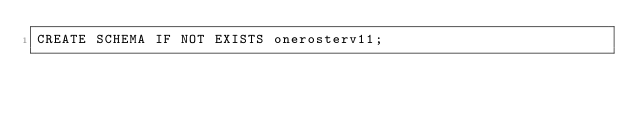Convert code to text. <code><loc_0><loc_0><loc_500><loc_500><_SQL_>CREATE SCHEMA IF NOT EXISTS onerosterv11;</code> 